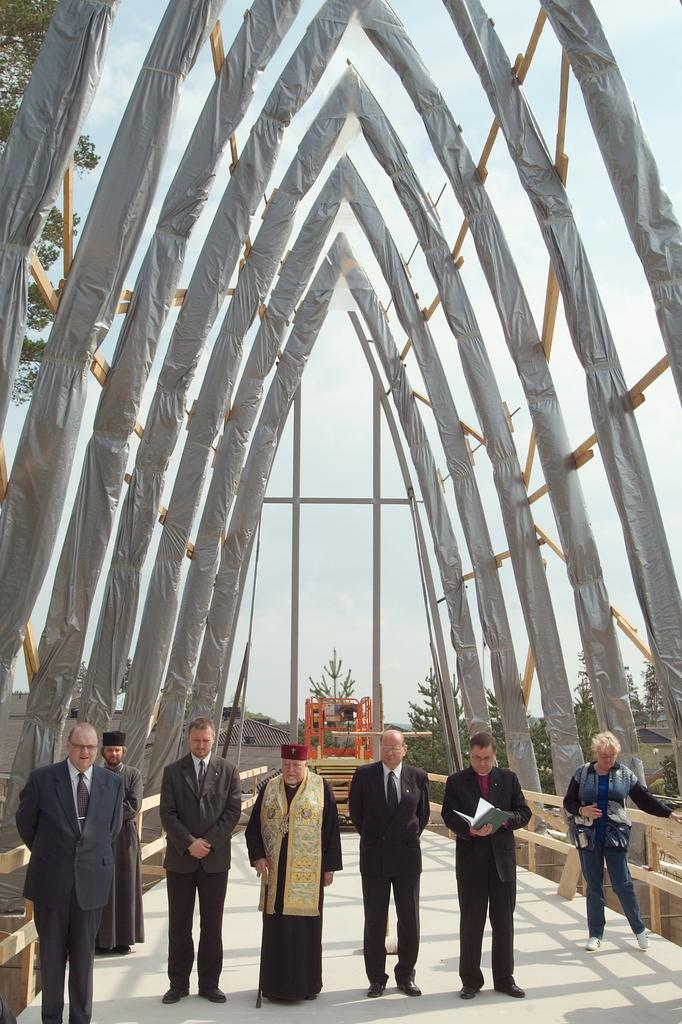What are the people in the image doing? The people in the image are standing on the floor in the center of the image. What can be seen at the top of the image? There are wooden rods at the top of the image. What is visible in the background of the image? The sky and trees are visible in the background of the image. What type of door can be seen in the image? There is no door present in the image. What is the tongue of the person in the image doing? There is no person's tongue visible in the image. 